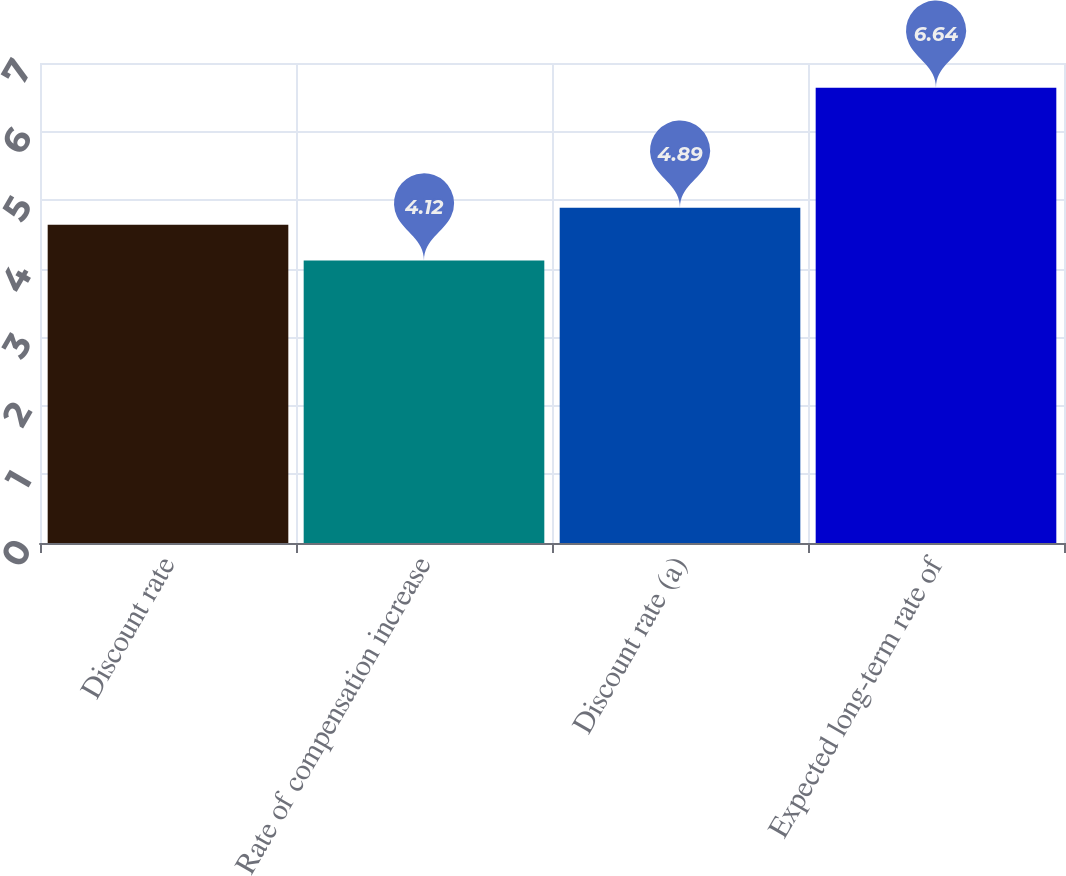<chart> <loc_0><loc_0><loc_500><loc_500><bar_chart><fcel>Discount rate<fcel>Rate of compensation increase<fcel>Discount rate (a)<fcel>Expected long-term rate of<nl><fcel>4.64<fcel>4.12<fcel>4.89<fcel>6.64<nl></chart> 